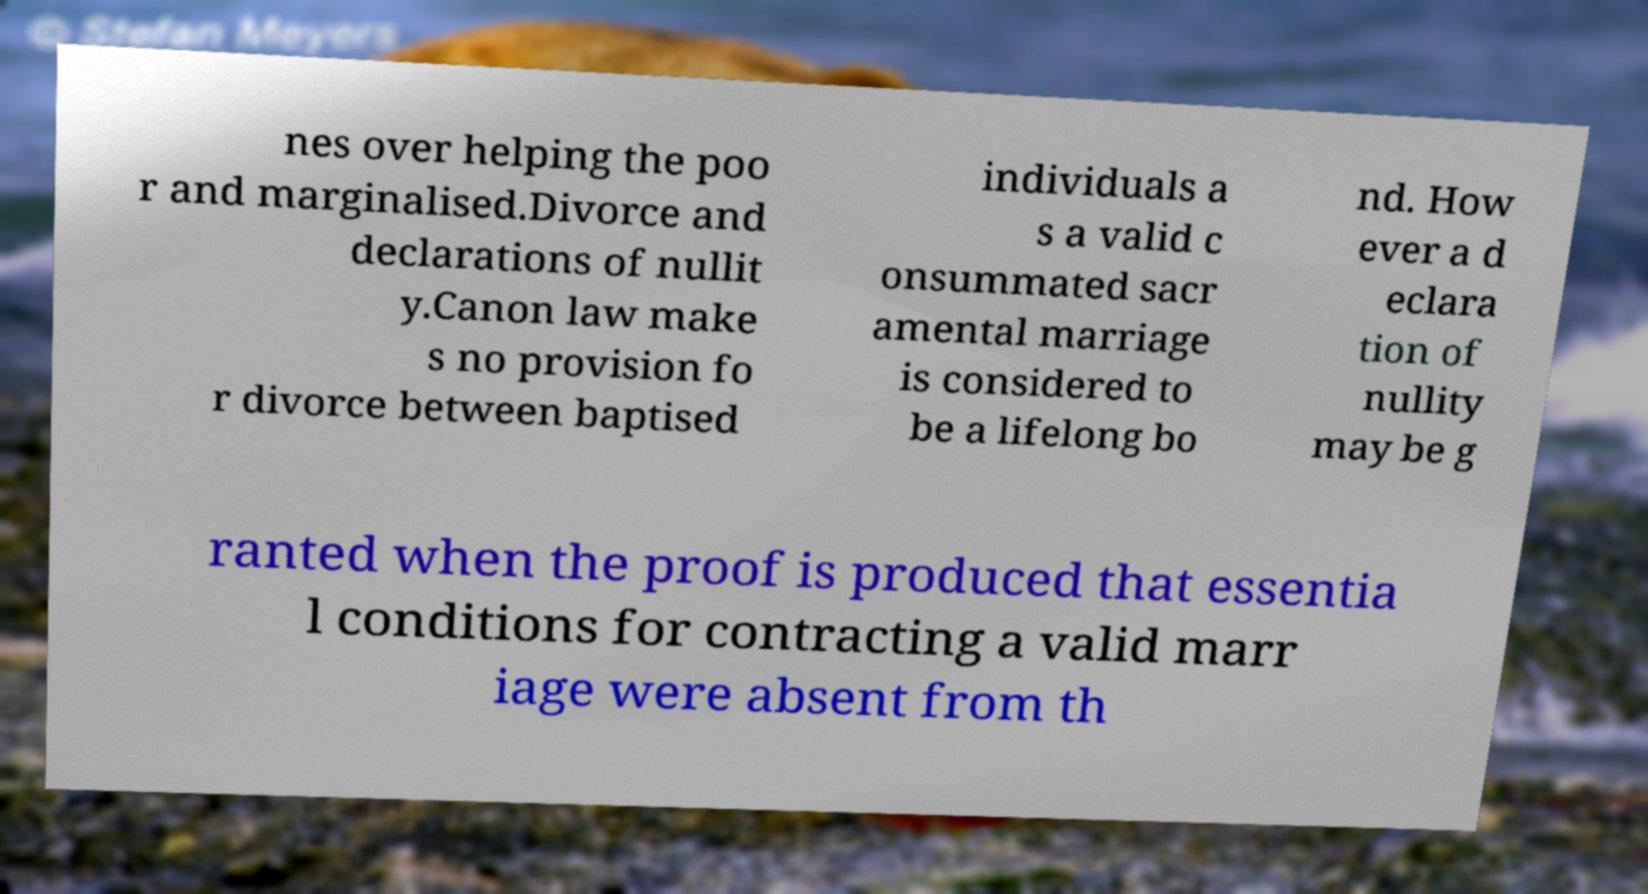Could you assist in decoding the text presented in this image and type it out clearly? nes over helping the poo r and marginalised.Divorce and declarations of nullit y.Canon law make s no provision fo r divorce between baptised individuals a s a valid c onsummated sacr amental marriage is considered to be a lifelong bo nd. How ever a d eclara tion of nullity may be g ranted when the proof is produced that essentia l conditions for contracting a valid marr iage were absent from th 